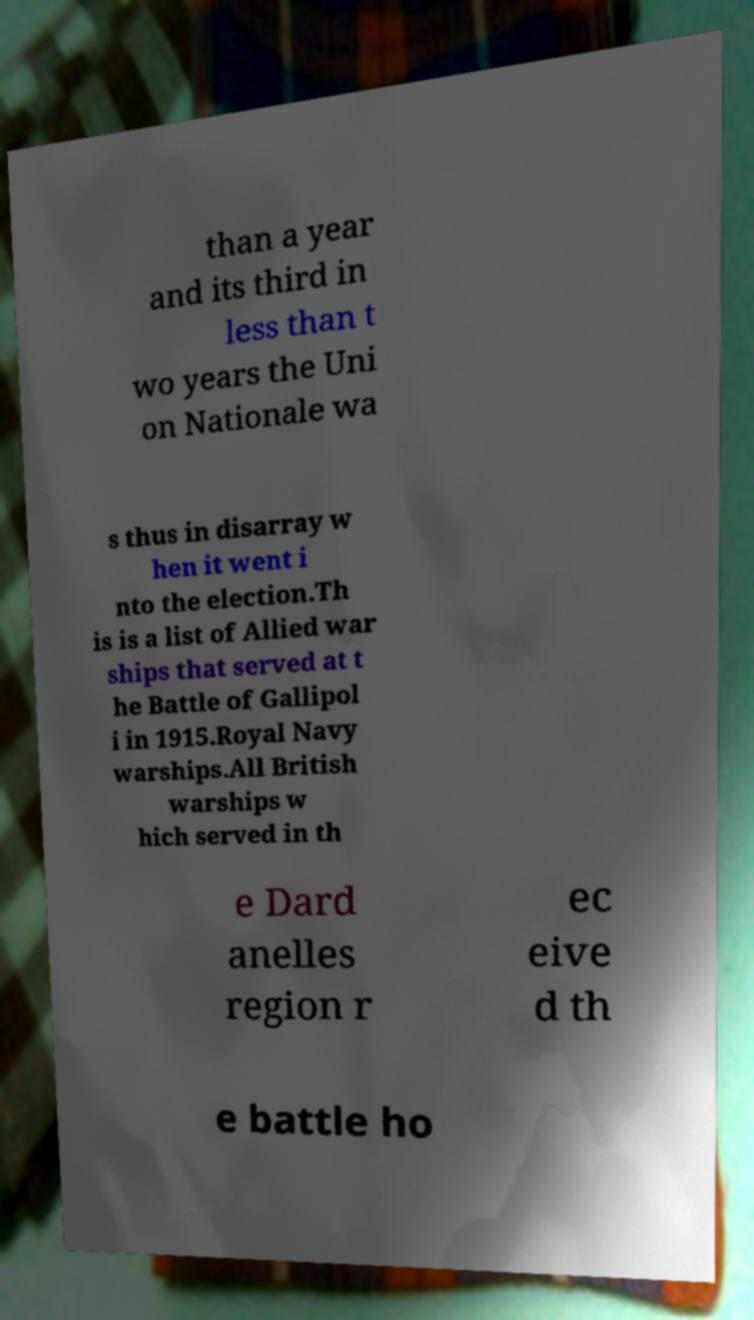There's text embedded in this image that I need extracted. Can you transcribe it verbatim? than a year and its third in less than t wo years the Uni on Nationale wa s thus in disarray w hen it went i nto the election.Th is is a list of Allied war ships that served at t he Battle of Gallipol i in 1915.Royal Navy warships.All British warships w hich served in th e Dard anelles region r ec eive d th e battle ho 